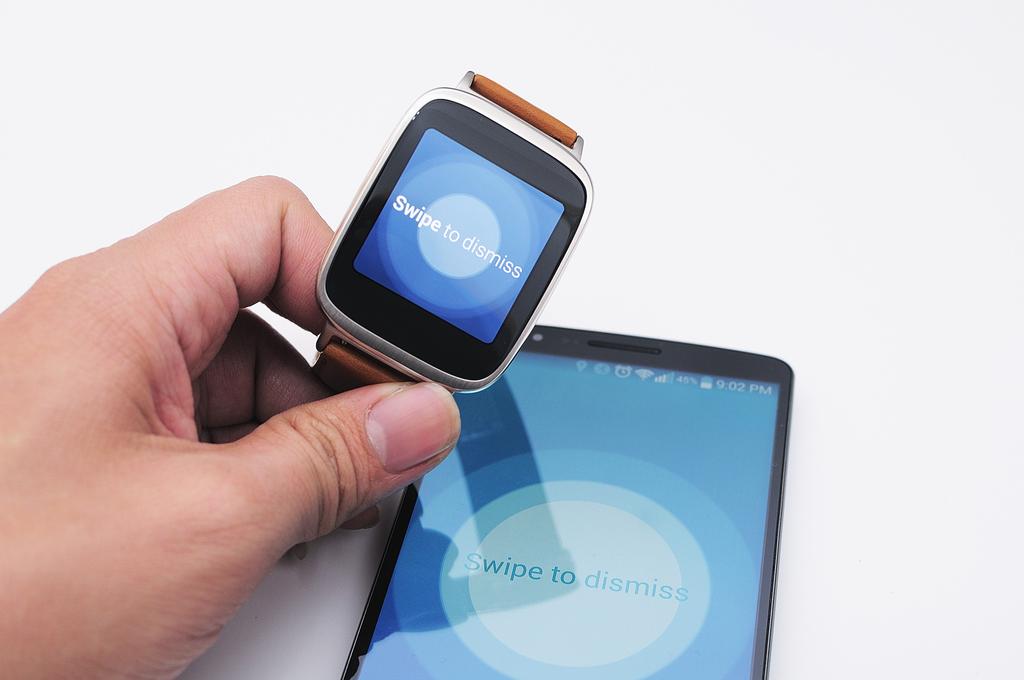How do you dismiss a notification?
Offer a very short reply. Swipe. Swipe to what?
Your answer should be compact. Dismiss. 